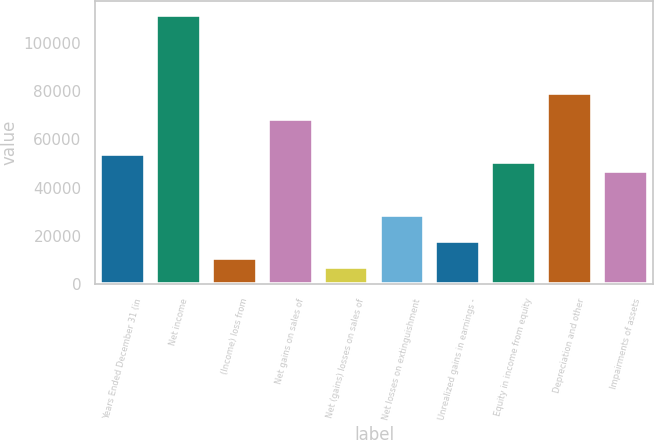Convert chart to OTSL. <chart><loc_0><loc_0><loc_500><loc_500><bar_chart><fcel>Years Ended December 31 (in<fcel>Net income<fcel>(Income) loss from<fcel>Net gains on sales of<fcel>Net (gains) losses on sales of<fcel>Net losses on extinguishment<fcel>Unrealized gains in earnings -<fcel>Equity in income from equity<fcel>Depreciation and other<fcel>Impairments of assets<nl><fcel>54063<fcel>111705<fcel>10831.8<fcel>68473.4<fcel>7229.2<fcel>28844.8<fcel>18037<fcel>50460.4<fcel>79281.2<fcel>46857.8<nl></chart> 